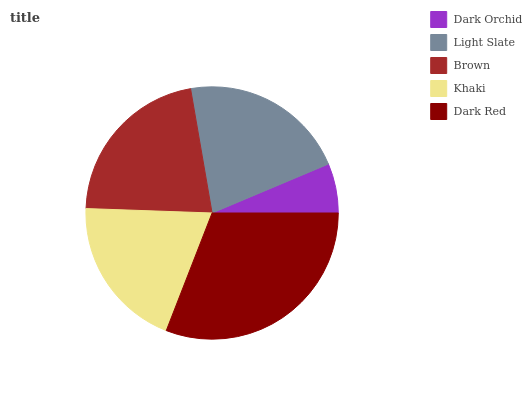Is Dark Orchid the minimum?
Answer yes or no. Yes. Is Dark Red the maximum?
Answer yes or no. Yes. Is Light Slate the minimum?
Answer yes or no. No. Is Light Slate the maximum?
Answer yes or no. No. Is Light Slate greater than Dark Orchid?
Answer yes or no. Yes. Is Dark Orchid less than Light Slate?
Answer yes or no. Yes. Is Dark Orchid greater than Light Slate?
Answer yes or no. No. Is Light Slate less than Dark Orchid?
Answer yes or no. No. Is Light Slate the high median?
Answer yes or no. Yes. Is Light Slate the low median?
Answer yes or no. Yes. Is Dark Red the high median?
Answer yes or no. No. Is Khaki the low median?
Answer yes or no. No. 